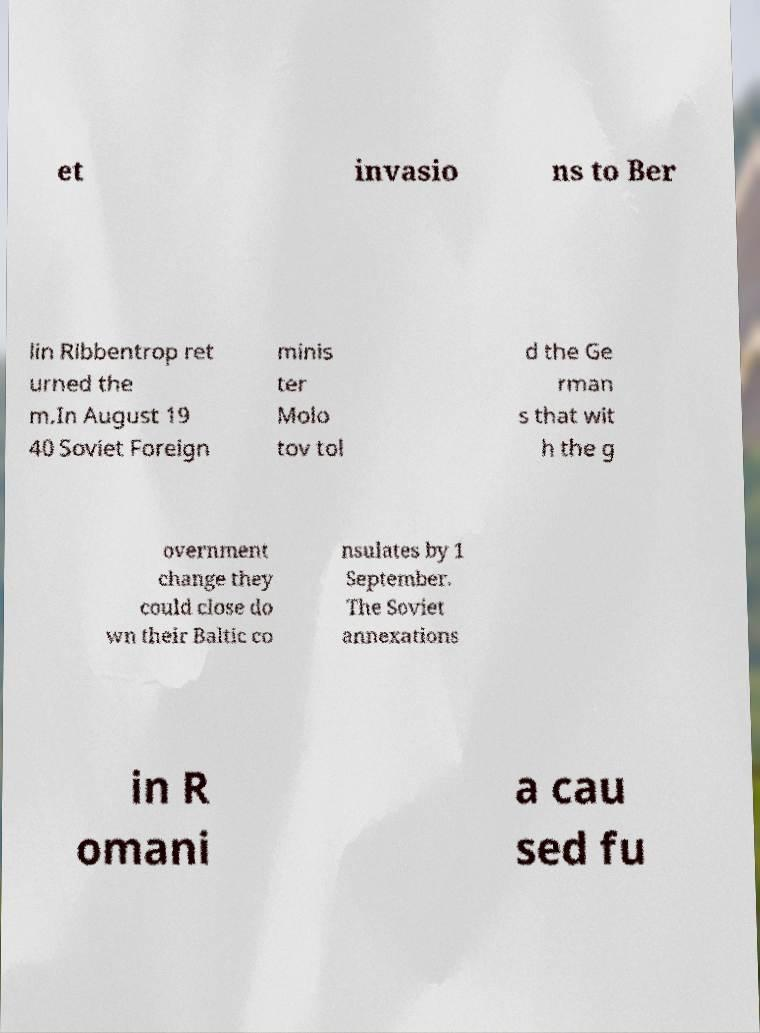For documentation purposes, I need the text within this image transcribed. Could you provide that? et invasio ns to Ber lin Ribbentrop ret urned the m.In August 19 40 Soviet Foreign minis ter Molo tov tol d the Ge rman s that wit h the g overnment change they could close do wn their Baltic co nsulates by 1 September. The Soviet annexations in R omani a cau sed fu 